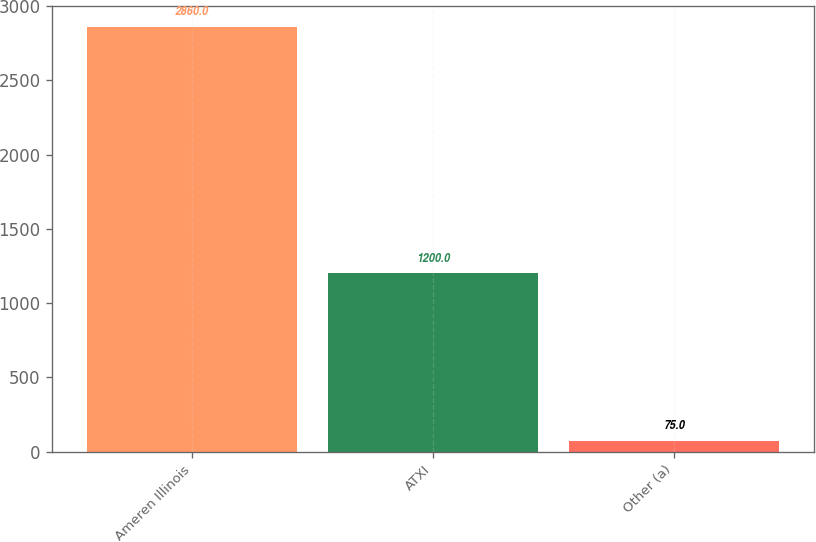Convert chart to OTSL. <chart><loc_0><loc_0><loc_500><loc_500><bar_chart><fcel>Ameren Illinois<fcel>ATXI<fcel>Other (a)<nl><fcel>2860<fcel>1200<fcel>75<nl></chart> 